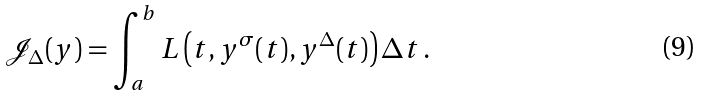Convert formula to latex. <formula><loc_0><loc_0><loc_500><loc_500>\mathcal { J } _ { \Delta } ( y ) = \int _ { a } ^ { b } L \left ( t , y ^ { \sigma } ( t ) , y ^ { \Delta } ( t ) \right ) \Delta t \, .</formula> 